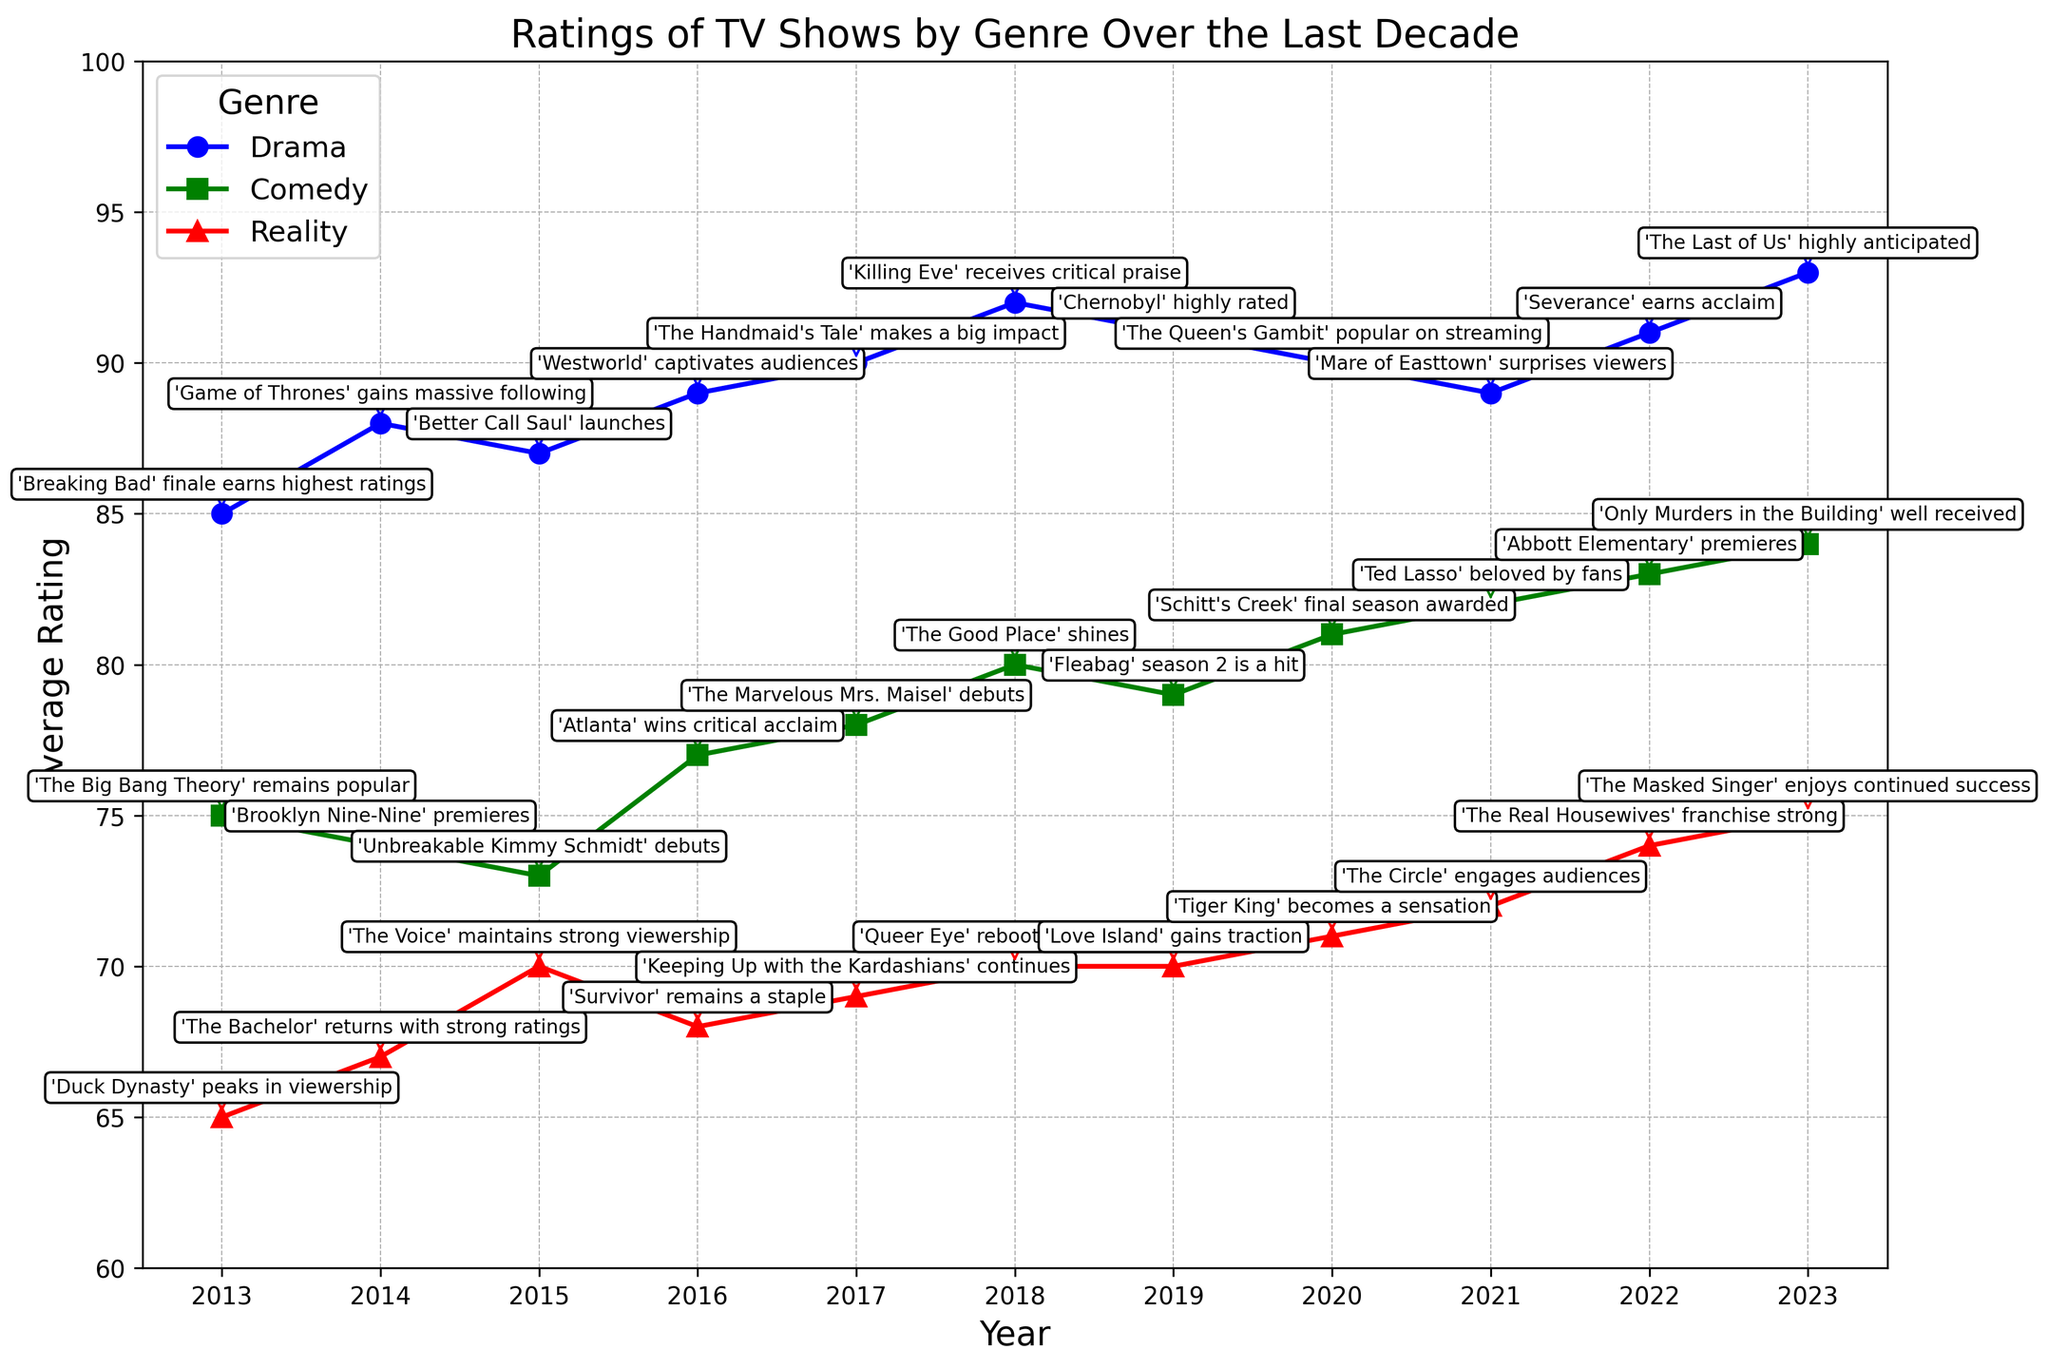What's the highest-rated Drama show in the decade? To find the highest-rated Drama show, look at the point with the highest rating along the Drama line (blue). The highest point occurs in 2023 with a rating of 93; the annotation states "'The Last of Us' highly anticipated."
Answer: 'The Last of Us' Which genre had the lowest average rating in 2013? Compare the positions of the points for each genre in 2013. The red point (Reality) is the lowest with a rating of 65, indicated by the annotation "'Duck Dynasty' peaks in viewership."
Answer: Reality How did the average rating for Reality shows change from 2014 to 2020? Locate the points for Reality (red) in 2014 and 2020: 2014 has a rating of 67 and 2020 has a rating of 71. Calculate the difference: 71 - 67 = 4.
Answer: Increased by 4 Which year had the largest difference between Drama and Comedy ratings? Calculate the difference between Drama (blue) and Comedy (green) ratings for each year, and identify the year with the largest difference. The largest difference is in 2013: 85 (Drama) - 75 (Comedy) = 10.
Answer: 2013 In which year did Comedy shows receive the highest average rating, and what show was highlighted? Look for the highest point along the Comedy line (green). The highest point occurs in 2023 with an average rating of 84, highlighted by the annotation "'Only Murders in the Building' well received."
Answer: 2023; 'Only Murders in the Building' Compare the trend of ratings for Drama and Reality shows from 2015 to 2020. Which genre improved more? Identify the ratings for Drama and Reality from 2015 to 2020: Drama (87 to 90) increased by 3 and Reality (70 to 71) increased by 1. Compare the increases: 3 (Drama) > 1 (Reality).
Answer: Drama improved more How many genres had an average rating above 80 in 2022? Check each genre's rating point in 2022: Drama (91), Comedy (83), and Reality (74). Count the genres with ratings above 80, resulting in two genres (Drama and Comedy).
Answer: Two genres Which TV show debut in 2017 received significant critical acclaim, according to the figure? Look for a debut show in 2017 with notable annotations. The Comedy line (green) shows the debut of 'The Marvelous Mrs. Maisel' with a rating of 78 and its annotation describing critical success.
Answer: 'The Marvelous Mrs. Maisel' What was the rating of the highest-rated Reality show, and in which year did it occur? Identify the highest point along the Reality line (red), which is in 2023 with a rating of 75, noted by the annotation "'The Masked Singer' enjoys continued success."
Answer: 75 in 2023 